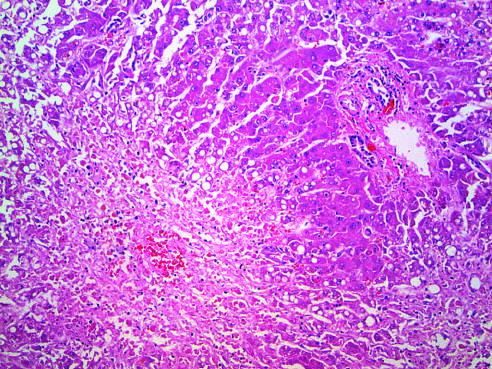what is indicated by the asterisk?
Answer the question using a single word or phrase. Residual normal tissue 